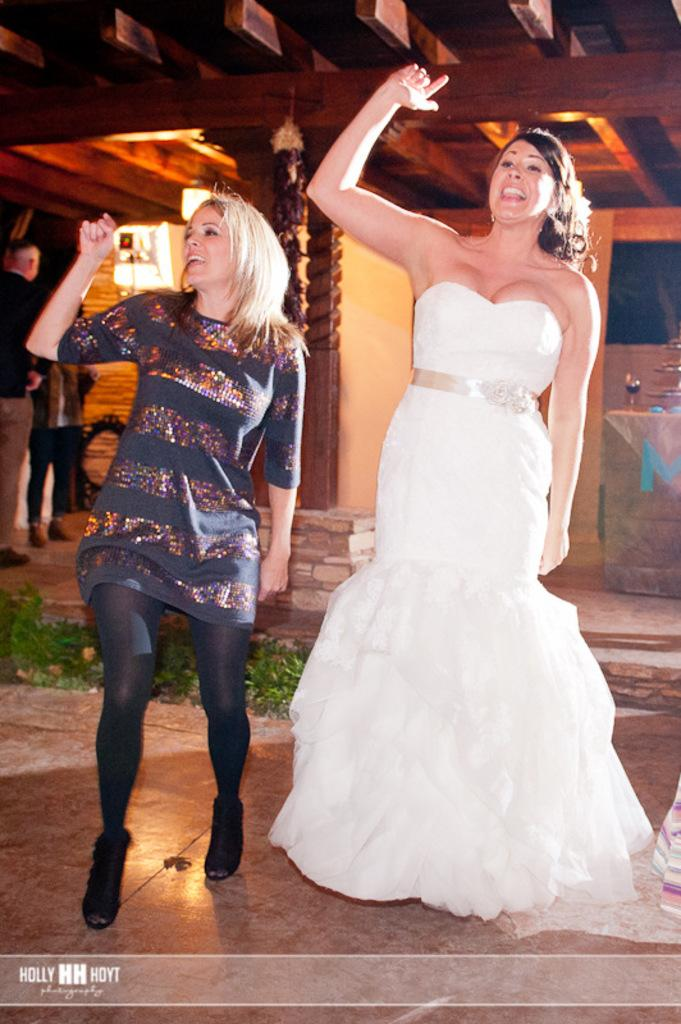What are the two people in the image doing? The two people in the image are dancing. What type of structure is visible in the image? There is a wooden roof in the image. What can be seen illuminating the scene in the image? There are lights in the image. What is visible in the background of the image? There is a wall and glass in the background of the image. Are there any other people present in the image? Yes, there are two people standing in the background of the image. What type of toothbrush is the authority using in the image? There is no authority or toothbrush present in the image. 